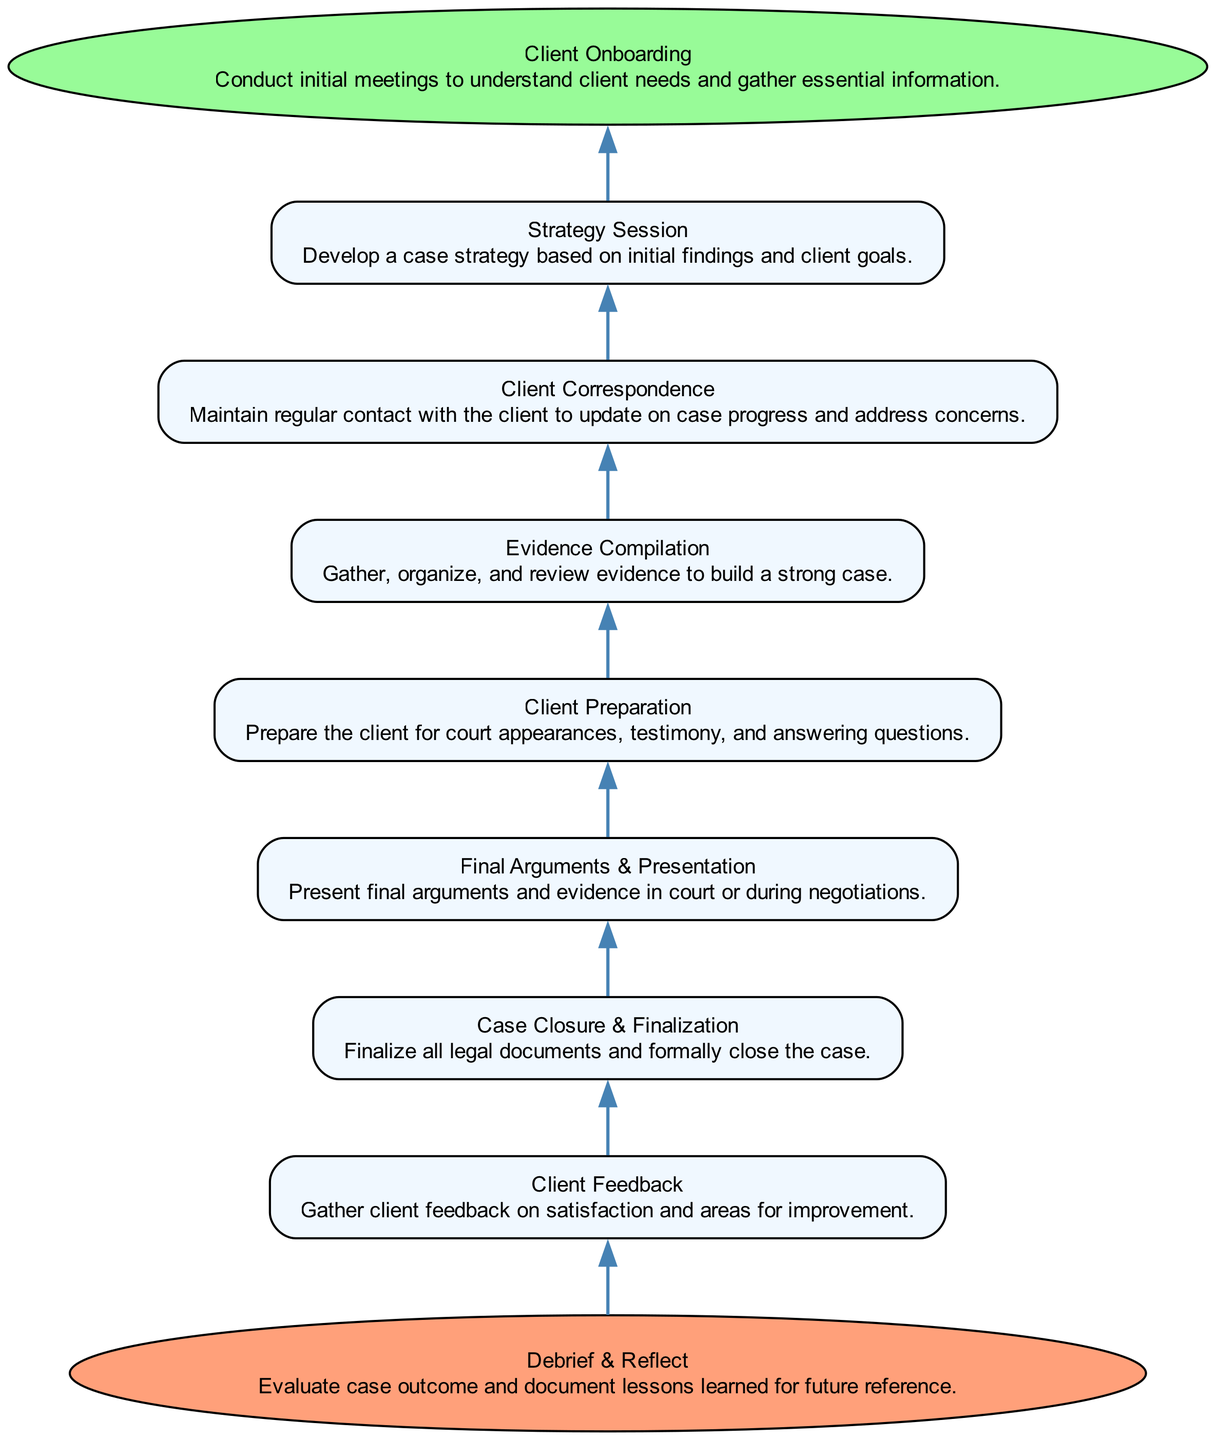What's the first step in managing a high-stress client case? The first step is "Client Onboarding," which involves conducting initial meetings to understand client needs and gather essential information.
Answer: Client Onboarding How many nodes are in the diagram? By counting each distinct element listed in the flowchart, there are a total of 8 nodes present.
Answer: 8 Which process comes immediately before "Final Arguments & Presentation"? The process that comes immediately before "Final Arguments & Presentation" is "Client Preparation," indicating the need to prepare the client beforehand.
Answer: Client Preparation What is the last action taken in this flowchart? The last action is "Debrief & Reflect," which signifies evaluating the case outcome and documenting lessons learned.
Answer: Debrief & Reflect Which two processes lead to "Case Closure & Finalization"? "Final Arguments & Presentation" and "Client Feedback" are the two processes that lead into "Case Closure & Finalization," suggesting they are precursors to closing the case.
Answer: Final Arguments & Presentation; Client Feedback Is "Strategy Session" positioned above or below "Client Correspondence"? "Strategy Session" is positioned above "Client Correspondence," indicating the need for strategy development before maintaining client contact.
Answer: Above What type of node is "Debrief & Reflect"? "Debrief & Reflect" is classified as an "End" node, indicating it marks the conclusion of the flowchart.
Answer: End Which process directly follows "Evidence Compilation"? The process that directly follows "Evidence Compilation" in the flow is "Client Preparation," indicating the next step in the case management process.
Answer: Client Preparation 